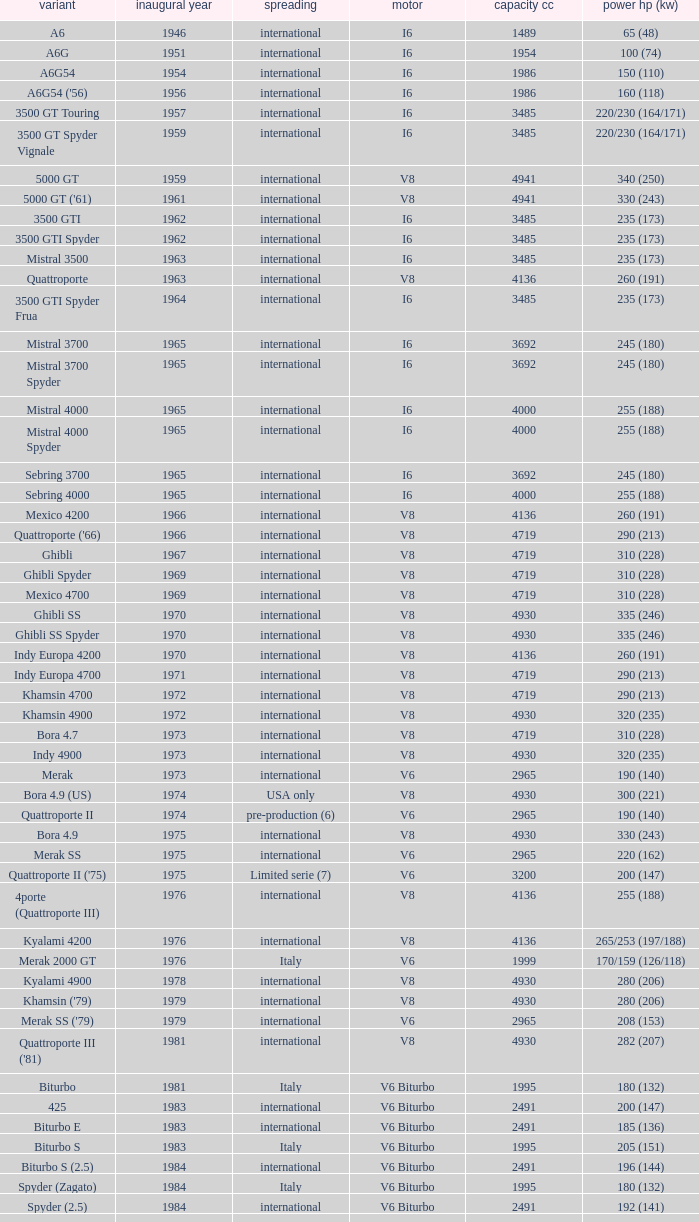What is the lowest First Year, when Model is "Quattroporte (2.8)"? 1994.0. 